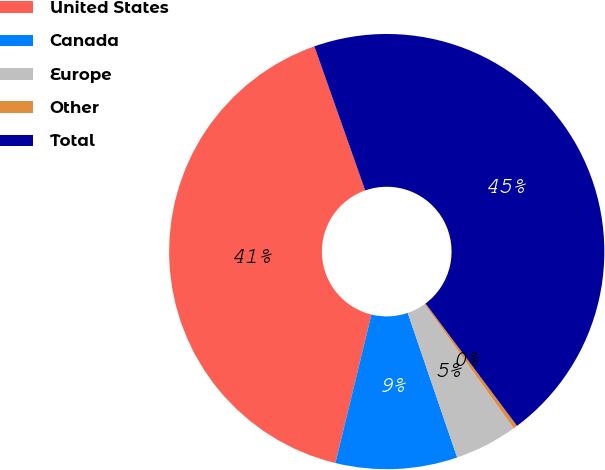Convert chart. <chart><loc_0><loc_0><loc_500><loc_500><pie_chart><fcel>United States<fcel>Canada<fcel>Europe<fcel>Other<fcel>Total<nl><fcel>40.81%<fcel>9.04%<fcel>4.67%<fcel>0.3%<fcel>45.18%<nl></chart> 